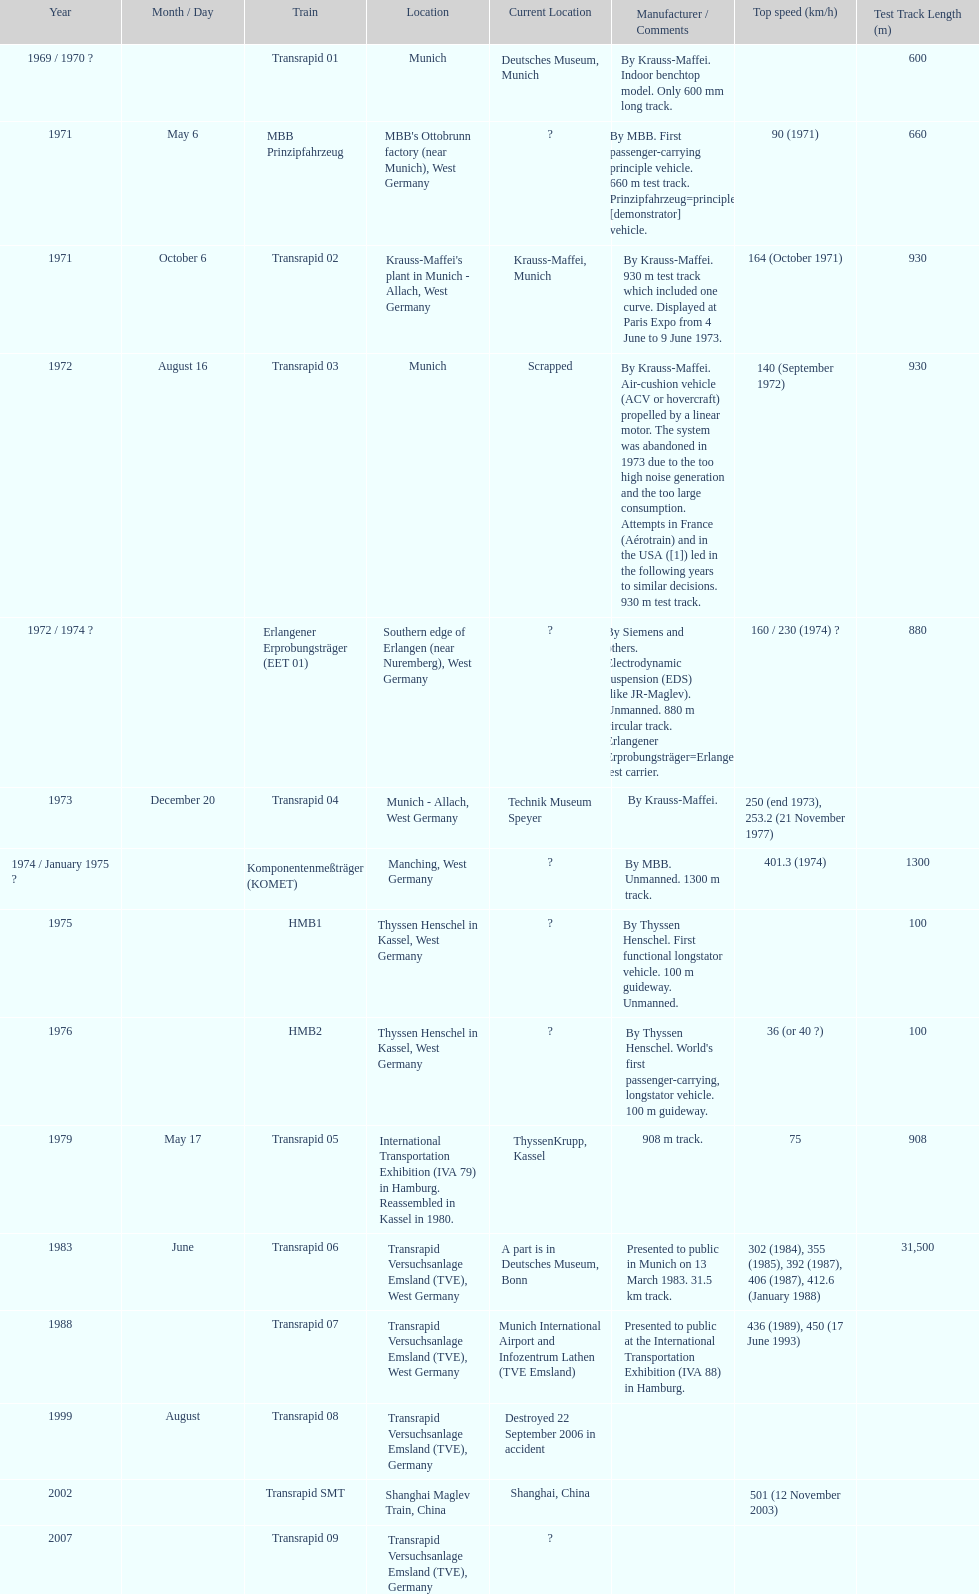What train was developed after the erlangener erprobungstrager? Transrapid 04. 